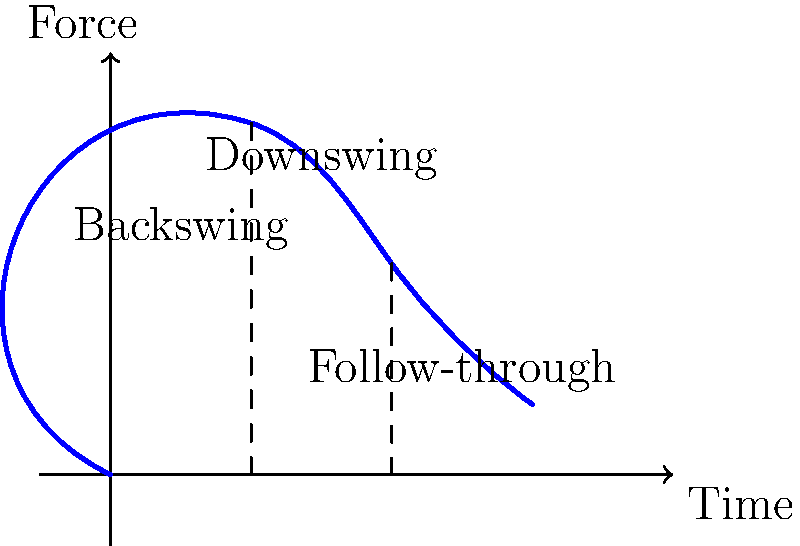In a golf swing, which phase typically generates the most force and how can this principle be applied to business networking strategies? To answer this question, let's analyze the golf swing force curve and draw parallels to business networking:

1. Backswing phase:
   - In golf: This is the preparation phase, building potential energy.
   - In networking: This represents preparation and research before an event.

2. Downswing phase:
   - In golf: This is where the most force is generated, as shown by the peak in the graph.
   - In networking: This corresponds to the actual interaction at an event, where the most "impact" is made.

3. Follow-through phase:
   - In golf: The force decreases as the swing completes.
   - In networking: This represents follow-up actions after the event.

The downswing phase generates the most force in a golf swing, as evidenced by the highest point on the curve. This principle can be applied to business networking by focusing efforts on the actual interaction phase:

1. Prepare thoroughly (backswing)
2. Deliver a strong, impactful interaction (downswing)
3. Follow up consistently (follow-through)

By concentrating energy and resources on the "downswing" phase of networking (i.e., the actual interaction), business owners can maximize their impact and potentially yield better results from their networking efforts.
Answer: Downswing; focus on impactful interactions 